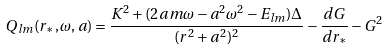<formula> <loc_0><loc_0><loc_500><loc_500>Q _ { l m } ( r _ { \ast } , \omega , a ) = \frac { K ^ { 2 } + ( 2 a m \omega - a ^ { 2 } \omega ^ { 2 } - E _ { l m } ) \Delta } { ( r ^ { 2 } + a ^ { 2 } ) ^ { 2 } } - \frac { d G } { d r _ { \ast } } - G ^ { 2 }</formula> 